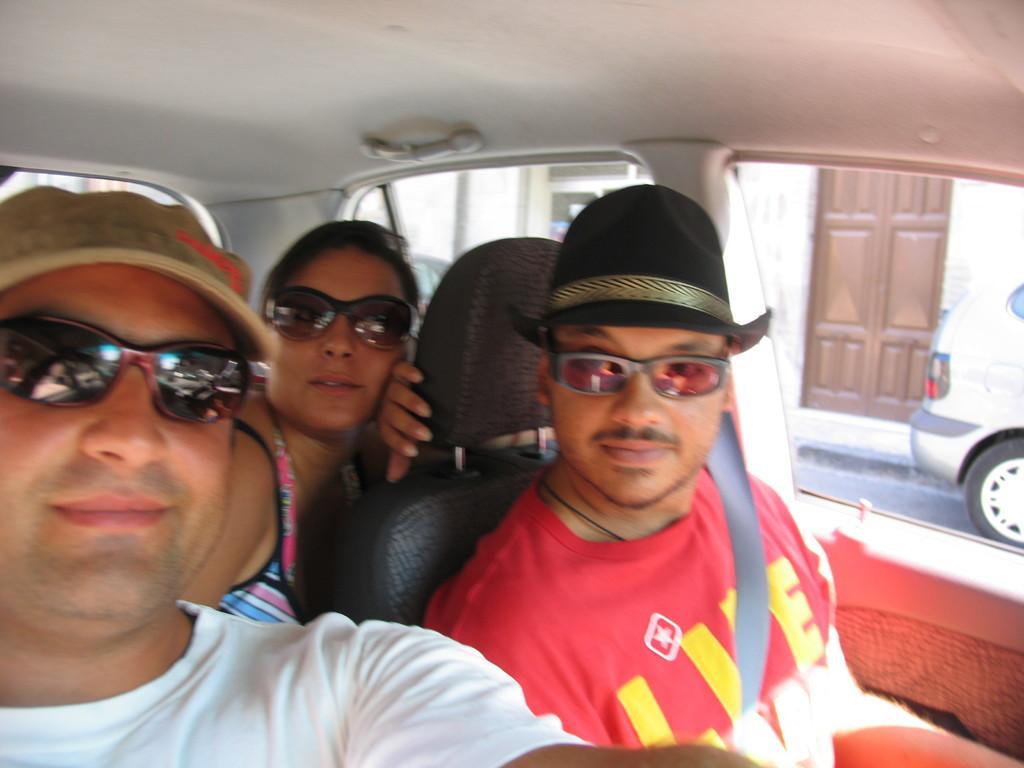Can you describe this image briefly? In this picture we can see three people are seated in the car, in the background we can find a car and a building. 